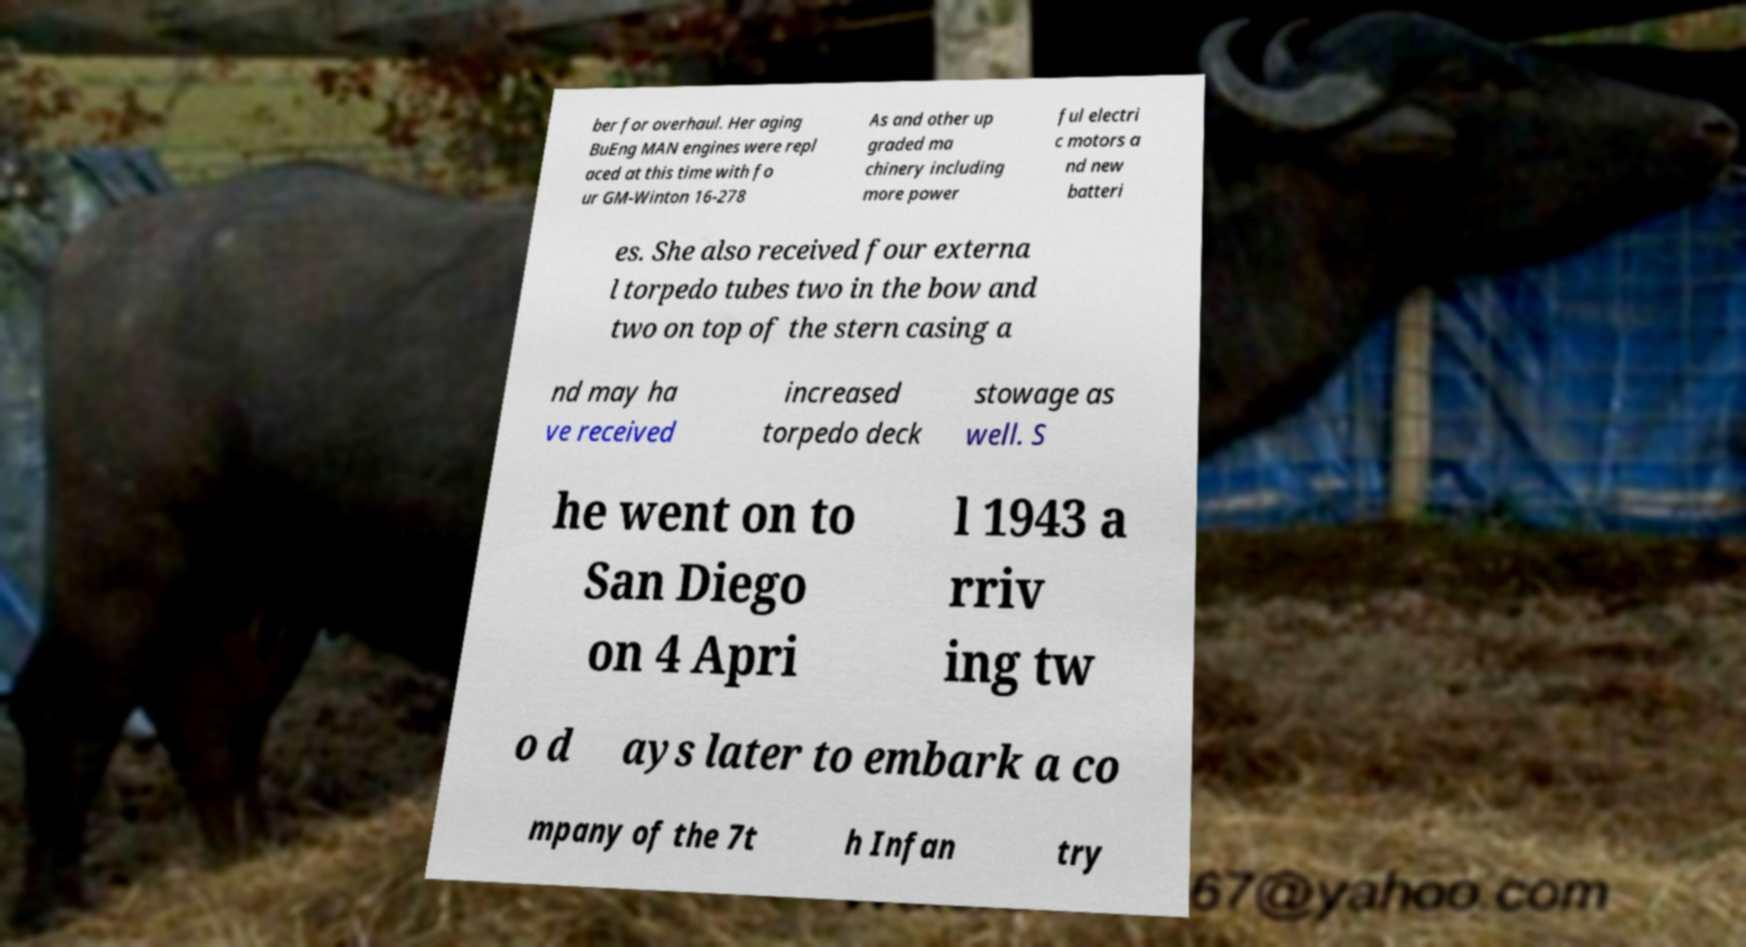Please identify and transcribe the text found in this image. ber for overhaul. Her aging BuEng MAN engines were repl aced at this time with fo ur GM-Winton 16-278 As and other up graded ma chinery including more power ful electri c motors a nd new batteri es. She also received four externa l torpedo tubes two in the bow and two on top of the stern casing a nd may ha ve received increased torpedo deck stowage as well. S he went on to San Diego on 4 Apri l 1943 a rriv ing tw o d ays later to embark a co mpany of the 7t h Infan try 